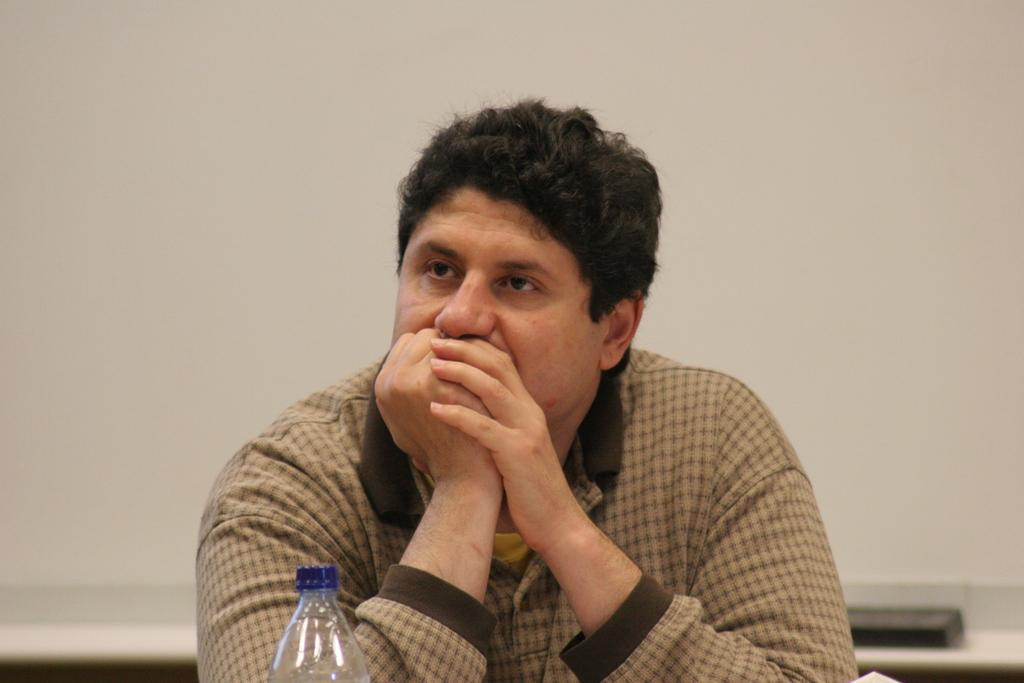What is the person in the room doing? There is a person sitting in the room. What furniture is present in the room? There is a table in the room. What object is on the table? There is a bottle on the table. What is the person's hand doing in relation to the bottle? The person's hand is near the mouth of the bottle. What type of dinner is the giraffe eating in the image? There is no giraffe present in the image, so it is not possible to determine what type of dinner it might be eating. 